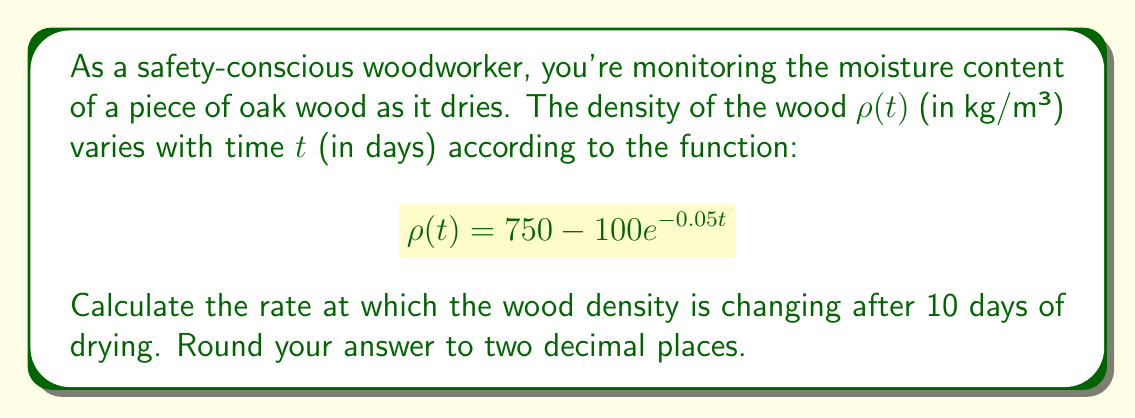Provide a solution to this math problem. To find the rate of change of wood density over time, we need to calculate the derivative of the density function $\rho(t)$ with respect to time $t$.

1. Given function: $\rho(t) = 750 - 100e^{-0.05t}$

2. To find the rate of change, we need to calculate $\frac{d\rho}{dt}$:
   $$\frac{d\rho}{dt} = \frac{d}{dt}(750 - 100e^{-0.05t})$$

3. The derivative of a constant (750) is 0, so we only need to focus on the exponential term:
   $$\frac{d\rho}{dt} = -100 \cdot \frac{d}{dt}(e^{-0.05t})$$

4. Using the chain rule, we get:
   $$\frac{d\rho}{dt} = -100 \cdot (-0.05) \cdot e^{-0.05t}$$

5. Simplify:
   $$\frac{d\rho}{dt} = 5e^{-0.05t}$$

6. Now, we need to evaluate this at $t = 10$ days:
   $$\frac{d\rho}{dt}\bigg|_{t=10} = 5e^{-0.05(10)}$$

7. Calculate:
   $$\frac{d\rho}{dt}\bigg|_{t=10} = 5e^{-0.5} \approx 3.0327$$

8. Rounding to two decimal places:
   $$\frac{d\rho}{dt}\bigg|_{t=10} \approx 3.03 \text{ kg/m³/day}$$
Answer: The rate at which the wood density is changing after 10 days of drying is approximately $3.03$ kg/m³ per day. 